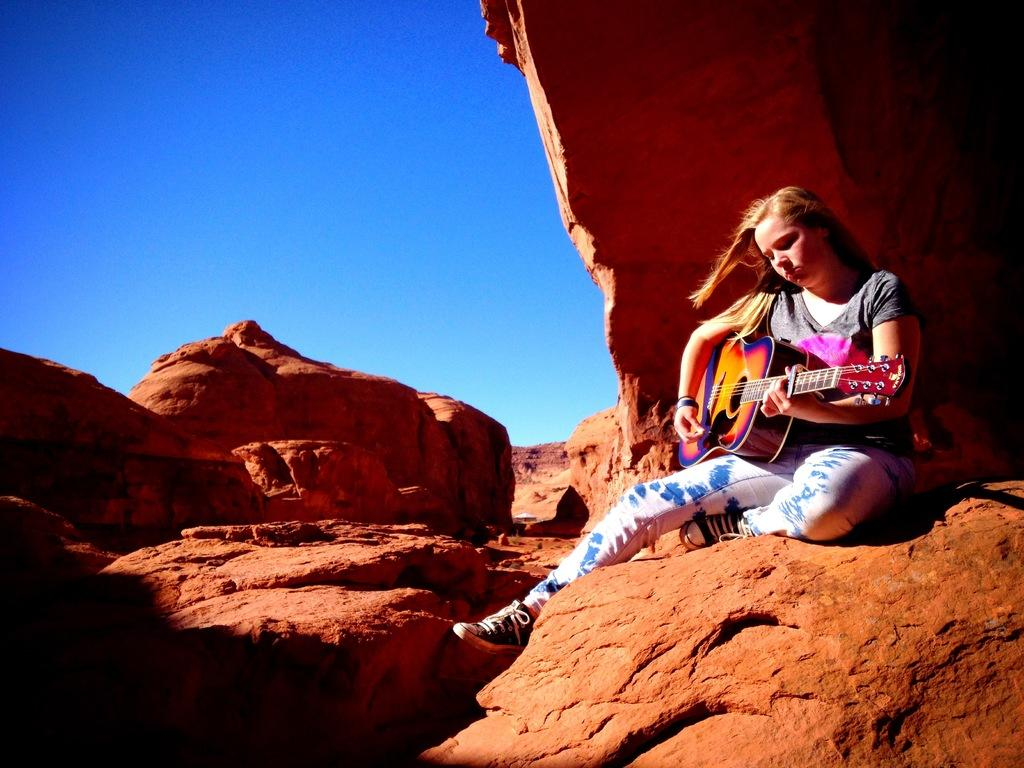Who is the main subject in the image? There is a woman in the image. What is the woman doing in the image? The woman is sitting on rocks. What object is the woman holding in the image? The woman is holding a guitar. What can be seen in the background of the image? There is sky visible in the background of the image. What type of cat is sitting next to the woman in the image? There is no cat present in the image. How many sisters does the woman in the image have? The provided facts do not mention any sisters, so we cannot determine the number of sisters the woman has. 